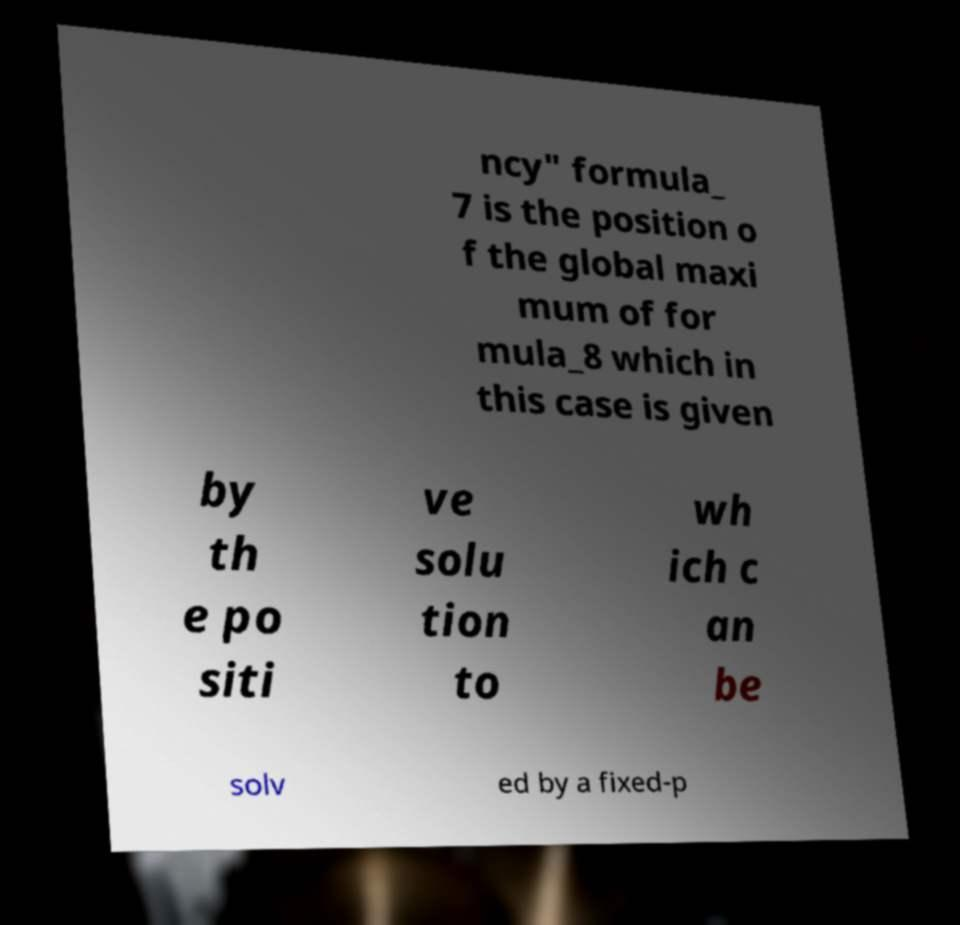I need the written content from this picture converted into text. Can you do that? ncy" formula_ 7 is the position o f the global maxi mum of for mula_8 which in this case is given by th e po siti ve solu tion to wh ich c an be solv ed by a fixed-p 